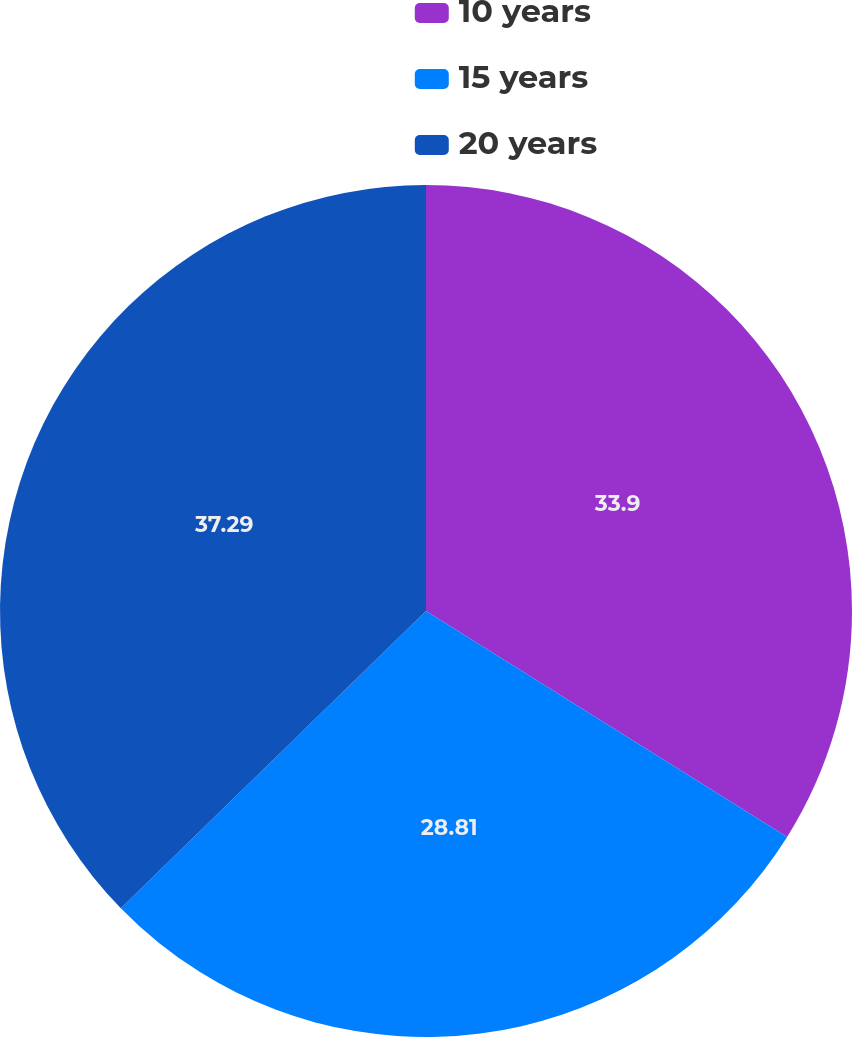<chart> <loc_0><loc_0><loc_500><loc_500><pie_chart><fcel>10 years<fcel>15 years<fcel>20 years<nl><fcel>33.9%<fcel>28.81%<fcel>37.29%<nl></chart> 